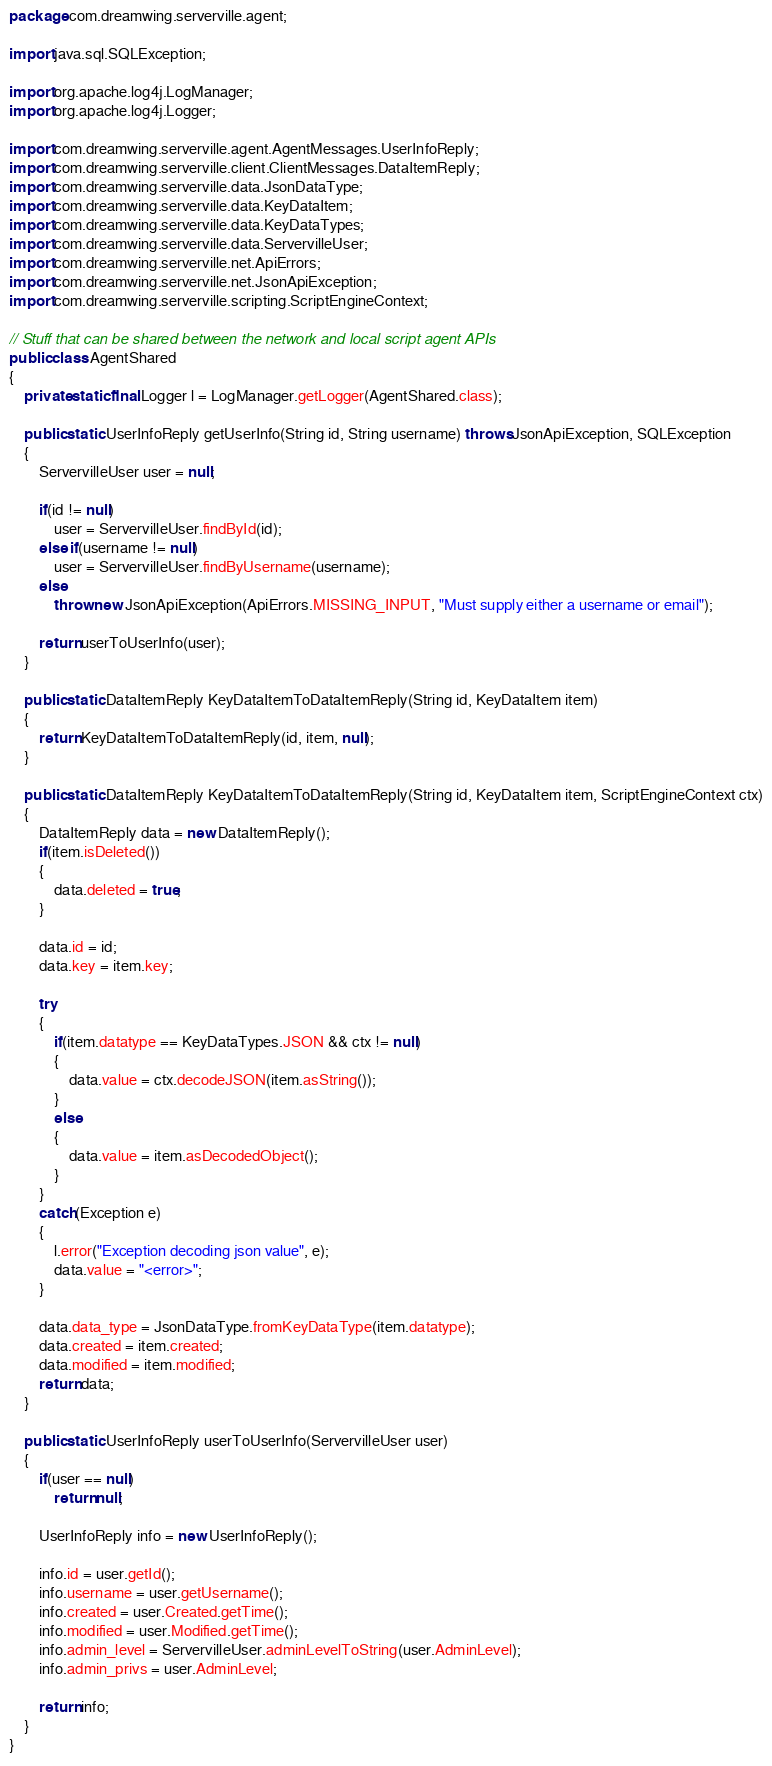Convert code to text. <code><loc_0><loc_0><loc_500><loc_500><_Java_>package com.dreamwing.serverville.agent;

import java.sql.SQLException;

import org.apache.log4j.LogManager;
import org.apache.log4j.Logger;

import com.dreamwing.serverville.agent.AgentMessages.UserInfoReply;
import com.dreamwing.serverville.client.ClientMessages.DataItemReply;
import com.dreamwing.serverville.data.JsonDataType;
import com.dreamwing.serverville.data.KeyDataItem;
import com.dreamwing.serverville.data.KeyDataTypes;
import com.dreamwing.serverville.data.ServervilleUser;
import com.dreamwing.serverville.net.ApiErrors;
import com.dreamwing.serverville.net.JsonApiException;
import com.dreamwing.serverville.scripting.ScriptEngineContext;

// Stuff that can be shared between the network and local script agent APIs
public class AgentShared
{
	private static final Logger l = LogManager.getLogger(AgentShared.class);
	
	public static UserInfoReply getUserInfo(String id, String username) throws JsonApiException, SQLException
	{
		ServervilleUser user = null;

		if(id != null)
			user = ServervilleUser.findById(id);
		else if(username != null)
			user = ServervilleUser.findByUsername(username);
		else
			throw new JsonApiException(ApiErrors.MISSING_INPUT, "Must supply either a username or email");
		
		return userToUserInfo(user);
	}
	
	public static DataItemReply KeyDataItemToDataItemReply(String id, KeyDataItem item)
	{
		return KeyDataItemToDataItemReply(id, item, null);
	}
	
	public static DataItemReply KeyDataItemToDataItemReply(String id, KeyDataItem item, ScriptEngineContext ctx)
	{
		DataItemReply data = new DataItemReply();
		if(item.isDeleted())
		{
			data.deleted = true;
		}
		
		data.id = id;
		data.key = item.key;
		
		try
		{
			if(item.datatype == KeyDataTypes.JSON && ctx != null)
			{
				data.value = ctx.decodeJSON(item.asString());
			}
			else
			{
				data.value = item.asDecodedObject();
			}
		}
		catch(Exception e)
		{
			l.error("Exception decoding json value", e);
			data.value = "<error>";
		}
		
		data.data_type = JsonDataType.fromKeyDataType(item.datatype);
		data.created = item.created;
		data.modified = item.modified;
		return data;
	}
	
	public static UserInfoReply userToUserInfo(ServervilleUser user)
	{
		if(user == null)
			return null;
		
		UserInfoReply info = new UserInfoReply();
		
		info.id = user.getId();
		info.username = user.getUsername();
		info.created = user.Created.getTime();
		info.modified = user.Modified.getTime();
		info.admin_level = ServervilleUser.adminLevelToString(user.AdminLevel);
		info.admin_privs = user.AdminLevel;
		
		return info;
	}
}
</code> 